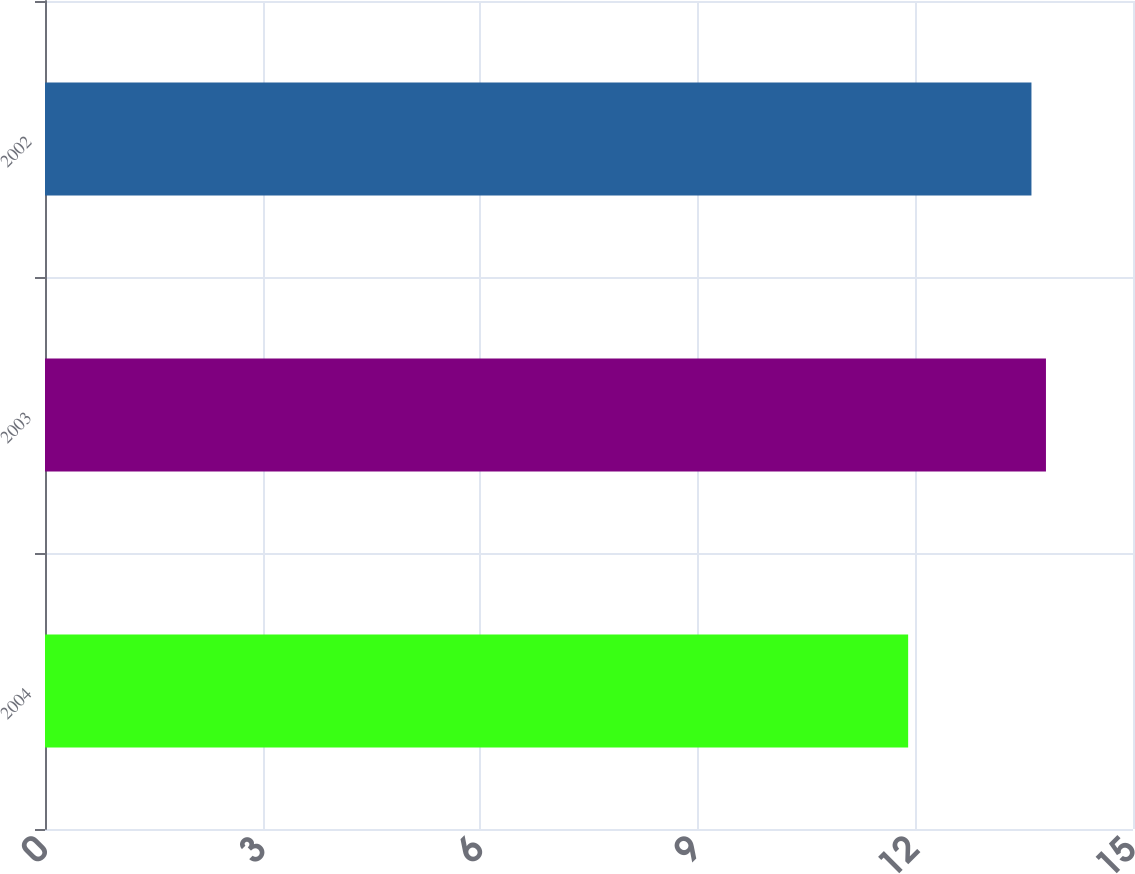<chart> <loc_0><loc_0><loc_500><loc_500><bar_chart><fcel>2004<fcel>2003<fcel>2002<nl><fcel>11.9<fcel>13.8<fcel>13.6<nl></chart> 